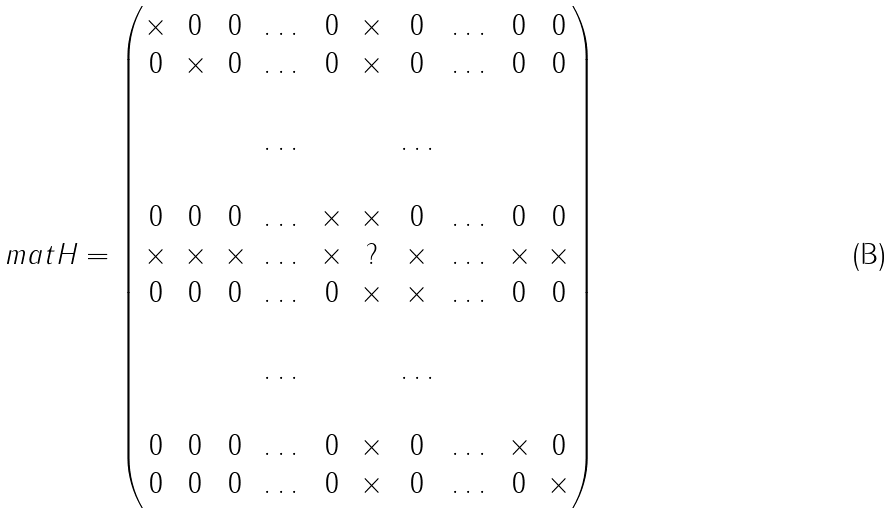Convert formula to latex. <formula><loc_0><loc_0><loc_500><loc_500>\ m a t { H } = \begin{pmatrix} \times & 0 & 0 & \dots & 0 & \times & 0 & \dots & 0 & 0 \\ 0 & \times & 0 & \dots & 0 & \times & 0 & \dots & 0 & 0 \\ \\ & & & \dots & & & \dots \\ \\ 0 & 0 & 0 & \dots & \times & \times & 0 & \dots & 0 & 0 \\ \times & \times & \times & \dots & \times & ? & \times & \dots & \times & \times \\ 0 & 0 & 0 & \dots & 0 & \times & \times & \dots & 0 & 0 \\ \\ & & & \dots & & & \dots \\ \\ 0 & 0 & 0 & \dots & 0 & \times & 0 & \dots & \times & 0 \\ 0 & 0 & 0 & \dots & 0 & \times & 0 & \dots & 0 & \times \end{pmatrix}</formula> 